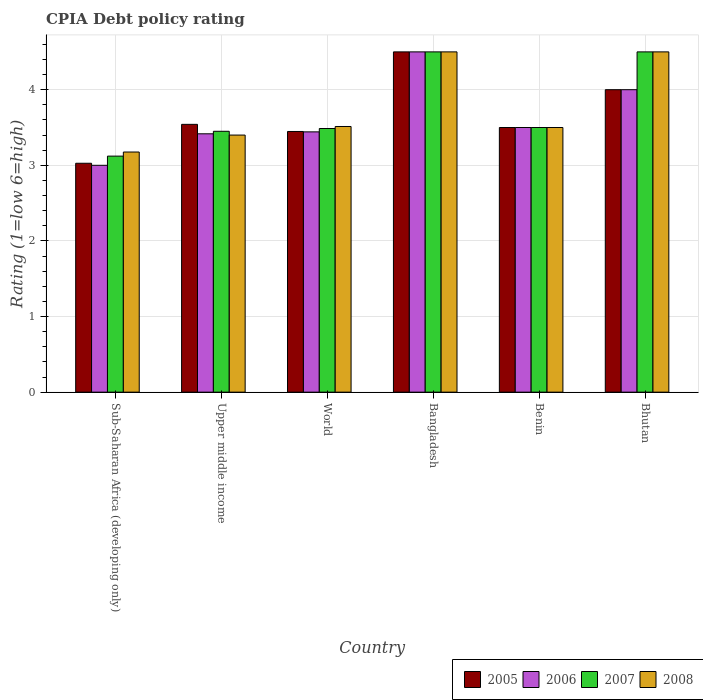How many different coloured bars are there?
Your response must be concise. 4. How many groups of bars are there?
Your answer should be compact. 6. Are the number of bars per tick equal to the number of legend labels?
Your response must be concise. Yes. How many bars are there on the 4th tick from the left?
Provide a short and direct response. 4. How many bars are there on the 5th tick from the right?
Give a very brief answer. 4. What is the label of the 5th group of bars from the left?
Make the answer very short. Benin. In how many cases, is the number of bars for a given country not equal to the number of legend labels?
Keep it short and to the point. 0. Across all countries, what is the maximum CPIA rating in 2005?
Provide a succinct answer. 4.5. Across all countries, what is the minimum CPIA rating in 2006?
Offer a terse response. 3. In which country was the CPIA rating in 2006 maximum?
Provide a short and direct response. Bangladesh. In which country was the CPIA rating in 2008 minimum?
Keep it short and to the point. Sub-Saharan Africa (developing only). What is the total CPIA rating in 2008 in the graph?
Provide a short and direct response. 22.59. What is the difference between the CPIA rating in 2007 in Bhutan and that in Sub-Saharan Africa (developing only)?
Make the answer very short. 1.38. What is the difference between the CPIA rating in 2005 in Sub-Saharan Africa (developing only) and the CPIA rating in 2007 in World?
Your answer should be very brief. -0.46. What is the average CPIA rating in 2006 per country?
Your answer should be compact. 3.64. What is the ratio of the CPIA rating in 2007 in Benin to that in Upper middle income?
Your answer should be compact. 1.01. What is the difference between the highest and the lowest CPIA rating in 2005?
Give a very brief answer. 1.47. What does the 3rd bar from the left in World represents?
Ensure brevity in your answer.  2007. How many bars are there?
Give a very brief answer. 24. Are all the bars in the graph horizontal?
Give a very brief answer. No. How many countries are there in the graph?
Make the answer very short. 6. What is the difference between two consecutive major ticks on the Y-axis?
Provide a short and direct response. 1. Does the graph contain any zero values?
Ensure brevity in your answer.  No. Does the graph contain grids?
Your response must be concise. Yes. How many legend labels are there?
Your response must be concise. 4. What is the title of the graph?
Offer a very short reply. CPIA Debt policy rating. What is the label or title of the X-axis?
Offer a terse response. Country. What is the Rating (1=low 6=high) of 2005 in Sub-Saharan Africa (developing only)?
Your answer should be very brief. 3.03. What is the Rating (1=low 6=high) in 2006 in Sub-Saharan Africa (developing only)?
Offer a terse response. 3. What is the Rating (1=low 6=high) in 2007 in Sub-Saharan Africa (developing only)?
Provide a short and direct response. 3.12. What is the Rating (1=low 6=high) in 2008 in Sub-Saharan Africa (developing only)?
Offer a very short reply. 3.18. What is the Rating (1=low 6=high) of 2005 in Upper middle income?
Provide a succinct answer. 3.54. What is the Rating (1=low 6=high) of 2006 in Upper middle income?
Your answer should be compact. 3.42. What is the Rating (1=low 6=high) of 2007 in Upper middle income?
Your answer should be very brief. 3.45. What is the Rating (1=low 6=high) of 2005 in World?
Offer a terse response. 3.45. What is the Rating (1=low 6=high) of 2006 in World?
Offer a very short reply. 3.44. What is the Rating (1=low 6=high) of 2007 in World?
Keep it short and to the point. 3.49. What is the Rating (1=low 6=high) in 2008 in World?
Offer a terse response. 3.51. What is the Rating (1=low 6=high) in 2005 in Bangladesh?
Provide a succinct answer. 4.5. What is the Rating (1=low 6=high) of 2006 in Bangladesh?
Provide a succinct answer. 4.5. What is the Rating (1=low 6=high) in 2007 in Bangladesh?
Offer a terse response. 4.5. What is the Rating (1=low 6=high) in 2006 in Benin?
Provide a succinct answer. 3.5. What is the Rating (1=low 6=high) in 2007 in Benin?
Offer a terse response. 3.5. What is the Rating (1=low 6=high) in 2008 in Benin?
Make the answer very short. 3.5. What is the Rating (1=low 6=high) of 2005 in Bhutan?
Your answer should be compact. 4. What is the Rating (1=low 6=high) in 2007 in Bhutan?
Offer a terse response. 4.5. What is the Rating (1=low 6=high) of 2008 in Bhutan?
Make the answer very short. 4.5. Across all countries, what is the maximum Rating (1=low 6=high) in 2005?
Offer a terse response. 4.5. Across all countries, what is the maximum Rating (1=low 6=high) of 2006?
Ensure brevity in your answer.  4.5. Across all countries, what is the maximum Rating (1=low 6=high) in 2007?
Give a very brief answer. 4.5. Across all countries, what is the maximum Rating (1=low 6=high) of 2008?
Offer a terse response. 4.5. Across all countries, what is the minimum Rating (1=low 6=high) in 2005?
Provide a succinct answer. 3.03. Across all countries, what is the minimum Rating (1=low 6=high) in 2007?
Ensure brevity in your answer.  3.12. Across all countries, what is the minimum Rating (1=low 6=high) of 2008?
Make the answer very short. 3.18. What is the total Rating (1=low 6=high) of 2005 in the graph?
Provide a succinct answer. 22.02. What is the total Rating (1=low 6=high) of 2006 in the graph?
Keep it short and to the point. 21.86. What is the total Rating (1=low 6=high) in 2007 in the graph?
Keep it short and to the point. 22.56. What is the total Rating (1=low 6=high) in 2008 in the graph?
Provide a short and direct response. 22.59. What is the difference between the Rating (1=low 6=high) in 2005 in Sub-Saharan Africa (developing only) and that in Upper middle income?
Provide a short and direct response. -0.51. What is the difference between the Rating (1=low 6=high) of 2006 in Sub-Saharan Africa (developing only) and that in Upper middle income?
Your response must be concise. -0.42. What is the difference between the Rating (1=low 6=high) in 2007 in Sub-Saharan Africa (developing only) and that in Upper middle income?
Your answer should be compact. -0.33. What is the difference between the Rating (1=low 6=high) in 2008 in Sub-Saharan Africa (developing only) and that in Upper middle income?
Give a very brief answer. -0.22. What is the difference between the Rating (1=low 6=high) in 2005 in Sub-Saharan Africa (developing only) and that in World?
Ensure brevity in your answer.  -0.42. What is the difference between the Rating (1=low 6=high) of 2006 in Sub-Saharan Africa (developing only) and that in World?
Your response must be concise. -0.44. What is the difference between the Rating (1=low 6=high) in 2007 in Sub-Saharan Africa (developing only) and that in World?
Your answer should be very brief. -0.36. What is the difference between the Rating (1=low 6=high) of 2008 in Sub-Saharan Africa (developing only) and that in World?
Your answer should be compact. -0.34. What is the difference between the Rating (1=low 6=high) of 2005 in Sub-Saharan Africa (developing only) and that in Bangladesh?
Provide a succinct answer. -1.47. What is the difference between the Rating (1=low 6=high) in 2007 in Sub-Saharan Africa (developing only) and that in Bangladesh?
Offer a terse response. -1.38. What is the difference between the Rating (1=low 6=high) in 2008 in Sub-Saharan Africa (developing only) and that in Bangladesh?
Keep it short and to the point. -1.32. What is the difference between the Rating (1=low 6=high) in 2005 in Sub-Saharan Africa (developing only) and that in Benin?
Your answer should be compact. -0.47. What is the difference between the Rating (1=low 6=high) of 2007 in Sub-Saharan Africa (developing only) and that in Benin?
Offer a terse response. -0.38. What is the difference between the Rating (1=low 6=high) of 2008 in Sub-Saharan Africa (developing only) and that in Benin?
Ensure brevity in your answer.  -0.32. What is the difference between the Rating (1=low 6=high) of 2005 in Sub-Saharan Africa (developing only) and that in Bhutan?
Keep it short and to the point. -0.97. What is the difference between the Rating (1=low 6=high) in 2007 in Sub-Saharan Africa (developing only) and that in Bhutan?
Make the answer very short. -1.38. What is the difference between the Rating (1=low 6=high) in 2008 in Sub-Saharan Africa (developing only) and that in Bhutan?
Offer a terse response. -1.32. What is the difference between the Rating (1=low 6=high) in 2005 in Upper middle income and that in World?
Offer a very short reply. 0.09. What is the difference between the Rating (1=low 6=high) of 2006 in Upper middle income and that in World?
Provide a short and direct response. -0.03. What is the difference between the Rating (1=low 6=high) in 2007 in Upper middle income and that in World?
Your answer should be compact. -0.04. What is the difference between the Rating (1=low 6=high) in 2008 in Upper middle income and that in World?
Offer a very short reply. -0.11. What is the difference between the Rating (1=low 6=high) of 2005 in Upper middle income and that in Bangladesh?
Provide a short and direct response. -0.96. What is the difference between the Rating (1=low 6=high) in 2006 in Upper middle income and that in Bangladesh?
Keep it short and to the point. -1.08. What is the difference between the Rating (1=low 6=high) in 2007 in Upper middle income and that in Bangladesh?
Give a very brief answer. -1.05. What is the difference between the Rating (1=low 6=high) in 2008 in Upper middle income and that in Bangladesh?
Keep it short and to the point. -1.1. What is the difference between the Rating (1=low 6=high) in 2005 in Upper middle income and that in Benin?
Your answer should be compact. 0.04. What is the difference between the Rating (1=low 6=high) in 2006 in Upper middle income and that in Benin?
Provide a short and direct response. -0.08. What is the difference between the Rating (1=low 6=high) in 2007 in Upper middle income and that in Benin?
Make the answer very short. -0.05. What is the difference between the Rating (1=low 6=high) of 2005 in Upper middle income and that in Bhutan?
Your answer should be compact. -0.46. What is the difference between the Rating (1=low 6=high) of 2006 in Upper middle income and that in Bhutan?
Make the answer very short. -0.58. What is the difference between the Rating (1=low 6=high) of 2007 in Upper middle income and that in Bhutan?
Keep it short and to the point. -1.05. What is the difference between the Rating (1=low 6=high) of 2005 in World and that in Bangladesh?
Provide a short and direct response. -1.05. What is the difference between the Rating (1=low 6=high) in 2006 in World and that in Bangladesh?
Provide a short and direct response. -1.06. What is the difference between the Rating (1=low 6=high) in 2007 in World and that in Bangladesh?
Offer a terse response. -1.01. What is the difference between the Rating (1=low 6=high) in 2008 in World and that in Bangladesh?
Offer a terse response. -0.99. What is the difference between the Rating (1=low 6=high) in 2005 in World and that in Benin?
Ensure brevity in your answer.  -0.05. What is the difference between the Rating (1=low 6=high) of 2006 in World and that in Benin?
Your answer should be compact. -0.06. What is the difference between the Rating (1=low 6=high) in 2007 in World and that in Benin?
Offer a terse response. -0.01. What is the difference between the Rating (1=low 6=high) in 2008 in World and that in Benin?
Offer a terse response. 0.01. What is the difference between the Rating (1=low 6=high) of 2005 in World and that in Bhutan?
Keep it short and to the point. -0.55. What is the difference between the Rating (1=low 6=high) of 2006 in World and that in Bhutan?
Ensure brevity in your answer.  -0.56. What is the difference between the Rating (1=low 6=high) in 2007 in World and that in Bhutan?
Your answer should be compact. -1.01. What is the difference between the Rating (1=low 6=high) of 2008 in World and that in Bhutan?
Your response must be concise. -0.99. What is the difference between the Rating (1=low 6=high) of 2006 in Bangladesh and that in Benin?
Offer a very short reply. 1. What is the difference between the Rating (1=low 6=high) in 2008 in Bangladesh and that in Benin?
Make the answer very short. 1. What is the difference between the Rating (1=low 6=high) in 2005 in Bangladesh and that in Bhutan?
Keep it short and to the point. 0.5. What is the difference between the Rating (1=low 6=high) of 2007 in Bangladesh and that in Bhutan?
Ensure brevity in your answer.  0. What is the difference between the Rating (1=low 6=high) of 2008 in Bangladesh and that in Bhutan?
Provide a succinct answer. 0. What is the difference between the Rating (1=low 6=high) of 2006 in Benin and that in Bhutan?
Ensure brevity in your answer.  -0.5. What is the difference between the Rating (1=low 6=high) in 2007 in Benin and that in Bhutan?
Your answer should be compact. -1. What is the difference between the Rating (1=low 6=high) of 2008 in Benin and that in Bhutan?
Give a very brief answer. -1. What is the difference between the Rating (1=low 6=high) in 2005 in Sub-Saharan Africa (developing only) and the Rating (1=low 6=high) in 2006 in Upper middle income?
Ensure brevity in your answer.  -0.39. What is the difference between the Rating (1=low 6=high) in 2005 in Sub-Saharan Africa (developing only) and the Rating (1=low 6=high) in 2007 in Upper middle income?
Your answer should be very brief. -0.42. What is the difference between the Rating (1=low 6=high) in 2005 in Sub-Saharan Africa (developing only) and the Rating (1=low 6=high) in 2008 in Upper middle income?
Your response must be concise. -0.37. What is the difference between the Rating (1=low 6=high) of 2006 in Sub-Saharan Africa (developing only) and the Rating (1=low 6=high) of 2007 in Upper middle income?
Your answer should be compact. -0.45. What is the difference between the Rating (1=low 6=high) of 2006 in Sub-Saharan Africa (developing only) and the Rating (1=low 6=high) of 2008 in Upper middle income?
Provide a short and direct response. -0.4. What is the difference between the Rating (1=low 6=high) of 2007 in Sub-Saharan Africa (developing only) and the Rating (1=low 6=high) of 2008 in Upper middle income?
Ensure brevity in your answer.  -0.28. What is the difference between the Rating (1=low 6=high) of 2005 in Sub-Saharan Africa (developing only) and the Rating (1=low 6=high) of 2006 in World?
Give a very brief answer. -0.42. What is the difference between the Rating (1=low 6=high) in 2005 in Sub-Saharan Africa (developing only) and the Rating (1=low 6=high) in 2007 in World?
Ensure brevity in your answer.  -0.46. What is the difference between the Rating (1=low 6=high) in 2005 in Sub-Saharan Africa (developing only) and the Rating (1=low 6=high) in 2008 in World?
Provide a succinct answer. -0.49. What is the difference between the Rating (1=low 6=high) in 2006 in Sub-Saharan Africa (developing only) and the Rating (1=low 6=high) in 2007 in World?
Keep it short and to the point. -0.49. What is the difference between the Rating (1=low 6=high) in 2006 in Sub-Saharan Africa (developing only) and the Rating (1=low 6=high) in 2008 in World?
Your answer should be very brief. -0.51. What is the difference between the Rating (1=low 6=high) in 2007 in Sub-Saharan Africa (developing only) and the Rating (1=low 6=high) in 2008 in World?
Give a very brief answer. -0.39. What is the difference between the Rating (1=low 6=high) in 2005 in Sub-Saharan Africa (developing only) and the Rating (1=low 6=high) in 2006 in Bangladesh?
Provide a succinct answer. -1.47. What is the difference between the Rating (1=low 6=high) of 2005 in Sub-Saharan Africa (developing only) and the Rating (1=low 6=high) of 2007 in Bangladesh?
Offer a terse response. -1.47. What is the difference between the Rating (1=low 6=high) in 2005 in Sub-Saharan Africa (developing only) and the Rating (1=low 6=high) in 2008 in Bangladesh?
Your response must be concise. -1.47. What is the difference between the Rating (1=low 6=high) in 2006 in Sub-Saharan Africa (developing only) and the Rating (1=low 6=high) in 2008 in Bangladesh?
Your response must be concise. -1.5. What is the difference between the Rating (1=low 6=high) of 2007 in Sub-Saharan Africa (developing only) and the Rating (1=low 6=high) of 2008 in Bangladesh?
Keep it short and to the point. -1.38. What is the difference between the Rating (1=low 6=high) of 2005 in Sub-Saharan Africa (developing only) and the Rating (1=low 6=high) of 2006 in Benin?
Provide a succinct answer. -0.47. What is the difference between the Rating (1=low 6=high) of 2005 in Sub-Saharan Africa (developing only) and the Rating (1=low 6=high) of 2007 in Benin?
Your answer should be compact. -0.47. What is the difference between the Rating (1=low 6=high) of 2005 in Sub-Saharan Africa (developing only) and the Rating (1=low 6=high) of 2008 in Benin?
Provide a succinct answer. -0.47. What is the difference between the Rating (1=low 6=high) of 2006 in Sub-Saharan Africa (developing only) and the Rating (1=low 6=high) of 2008 in Benin?
Keep it short and to the point. -0.5. What is the difference between the Rating (1=low 6=high) in 2007 in Sub-Saharan Africa (developing only) and the Rating (1=low 6=high) in 2008 in Benin?
Make the answer very short. -0.38. What is the difference between the Rating (1=low 6=high) in 2005 in Sub-Saharan Africa (developing only) and the Rating (1=low 6=high) in 2006 in Bhutan?
Your answer should be compact. -0.97. What is the difference between the Rating (1=low 6=high) in 2005 in Sub-Saharan Africa (developing only) and the Rating (1=low 6=high) in 2007 in Bhutan?
Provide a short and direct response. -1.47. What is the difference between the Rating (1=low 6=high) in 2005 in Sub-Saharan Africa (developing only) and the Rating (1=low 6=high) in 2008 in Bhutan?
Offer a terse response. -1.47. What is the difference between the Rating (1=low 6=high) of 2006 in Sub-Saharan Africa (developing only) and the Rating (1=low 6=high) of 2007 in Bhutan?
Offer a terse response. -1.5. What is the difference between the Rating (1=low 6=high) in 2006 in Sub-Saharan Africa (developing only) and the Rating (1=low 6=high) in 2008 in Bhutan?
Provide a short and direct response. -1.5. What is the difference between the Rating (1=low 6=high) of 2007 in Sub-Saharan Africa (developing only) and the Rating (1=low 6=high) of 2008 in Bhutan?
Make the answer very short. -1.38. What is the difference between the Rating (1=low 6=high) in 2005 in Upper middle income and the Rating (1=low 6=high) in 2006 in World?
Give a very brief answer. 0.1. What is the difference between the Rating (1=low 6=high) in 2005 in Upper middle income and the Rating (1=low 6=high) in 2007 in World?
Provide a short and direct response. 0.06. What is the difference between the Rating (1=low 6=high) of 2005 in Upper middle income and the Rating (1=low 6=high) of 2008 in World?
Ensure brevity in your answer.  0.03. What is the difference between the Rating (1=low 6=high) of 2006 in Upper middle income and the Rating (1=low 6=high) of 2007 in World?
Provide a succinct answer. -0.07. What is the difference between the Rating (1=low 6=high) of 2006 in Upper middle income and the Rating (1=low 6=high) of 2008 in World?
Ensure brevity in your answer.  -0.1. What is the difference between the Rating (1=low 6=high) of 2007 in Upper middle income and the Rating (1=low 6=high) of 2008 in World?
Provide a succinct answer. -0.06. What is the difference between the Rating (1=low 6=high) of 2005 in Upper middle income and the Rating (1=low 6=high) of 2006 in Bangladesh?
Your answer should be very brief. -0.96. What is the difference between the Rating (1=low 6=high) in 2005 in Upper middle income and the Rating (1=low 6=high) in 2007 in Bangladesh?
Offer a terse response. -0.96. What is the difference between the Rating (1=low 6=high) of 2005 in Upper middle income and the Rating (1=low 6=high) of 2008 in Bangladesh?
Offer a terse response. -0.96. What is the difference between the Rating (1=low 6=high) of 2006 in Upper middle income and the Rating (1=low 6=high) of 2007 in Bangladesh?
Offer a terse response. -1.08. What is the difference between the Rating (1=low 6=high) in 2006 in Upper middle income and the Rating (1=low 6=high) in 2008 in Bangladesh?
Provide a succinct answer. -1.08. What is the difference between the Rating (1=low 6=high) in 2007 in Upper middle income and the Rating (1=low 6=high) in 2008 in Bangladesh?
Offer a terse response. -1.05. What is the difference between the Rating (1=low 6=high) of 2005 in Upper middle income and the Rating (1=low 6=high) of 2006 in Benin?
Your response must be concise. 0.04. What is the difference between the Rating (1=low 6=high) of 2005 in Upper middle income and the Rating (1=low 6=high) of 2007 in Benin?
Offer a terse response. 0.04. What is the difference between the Rating (1=low 6=high) in 2005 in Upper middle income and the Rating (1=low 6=high) in 2008 in Benin?
Your answer should be very brief. 0.04. What is the difference between the Rating (1=low 6=high) in 2006 in Upper middle income and the Rating (1=low 6=high) in 2007 in Benin?
Your response must be concise. -0.08. What is the difference between the Rating (1=low 6=high) in 2006 in Upper middle income and the Rating (1=low 6=high) in 2008 in Benin?
Keep it short and to the point. -0.08. What is the difference between the Rating (1=low 6=high) in 2005 in Upper middle income and the Rating (1=low 6=high) in 2006 in Bhutan?
Make the answer very short. -0.46. What is the difference between the Rating (1=low 6=high) in 2005 in Upper middle income and the Rating (1=low 6=high) in 2007 in Bhutan?
Your answer should be very brief. -0.96. What is the difference between the Rating (1=low 6=high) in 2005 in Upper middle income and the Rating (1=low 6=high) in 2008 in Bhutan?
Offer a very short reply. -0.96. What is the difference between the Rating (1=low 6=high) of 2006 in Upper middle income and the Rating (1=low 6=high) of 2007 in Bhutan?
Your answer should be very brief. -1.08. What is the difference between the Rating (1=low 6=high) in 2006 in Upper middle income and the Rating (1=low 6=high) in 2008 in Bhutan?
Your response must be concise. -1.08. What is the difference between the Rating (1=low 6=high) of 2007 in Upper middle income and the Rating (1=low 6=high) of 2008 in Bhutan?
Your answer should be compact. -1.05. What is the difference between the Rating (1=low 6=high) of 2005 in World and the Rating (1=low 6=high) of 2006 in Bangladesh?
Provide a succinct answer. -1.05. What is the difference between the Rating (1=low 6=high) of 2005 in World and the Rating (1=low 6=high) of 2007 in Bangladesh?
Offer a very short reply. -1.05. What is the difference between the Rating (1=low 6=high) in 2005 in World and the Rating (1=low 6=high) in 2008 in Bangladesh?
Your answer should be very brief. -1.05. What is the difference between the Rating (1=low 6=high) of 2006 in World and the Rating (1=low 6=high) of 2007 in Bangladesh?
Keep it short and to the point. -1.06. What is the difference between the Rating (1=low 6=high) in 2006 in World and the Rating (1=low 6=high) in 2008 in Bangladesh?
Offer a very short reply. -1.06. What is the difference between the Rating (1=low 6=high) in 2007 in World and the Rating (1=low 6=high) in 2008 in Bangladesh?
Provide a succinct answer. -1.01. What is the difference between the Rating (1=low 6=high) in 2005 in World and the Rating (1=low 6=high) in 2006 in Benin?
Ensure brevity in your answer.  -0.05. What is the difference between the Rating (1=low 6=high) in 2005 in World and the Rating (1=low 6=high) in 2007 in Benin?
Your answer should be compact. -0.05. What is the difference between the Rating (1=low 6=high) of 2005 in World and the Rating (1=low 6=high) of 2008 in Benin?
Ensure brevity in your answer.  -0.05. What is the difference between the Rating (1=low 6=high) in 2006 in World and the Rating (1=low 6=high) in 2007 in Benin?
Ensure brevity in your answer.  -0.06. What is the difference between the Rating (1=low 6=high) in 2006 in World and the Rating (1=low 6=high) in 2008 in Benin?
Your answer should be compact. -0.06. What is the difference between the Rating (1=low 6=high) in 2007 in World and the Rating (1=low 6=high) in 2008 in Benin?
Your response must be concise. -0.01. What is the difference between the Rating (1=low 6=high) of 2005 in World and the Rating (1=low 6=high) of 2006 in Bhutan?
Your response must be concise. -0.55. What is the difference between the Rating (1=low 6=high) of 2005 in World and the Rating (1=low 6=high) of 2007 in Bhutan?
Keep it short and to the point. -1.05. What is the difference between the Rating (1=low 6=high) of 2005 in World and the Rating (1=low 6=high) of 2008 in Bhutan?
Your answer should be very brief. -1.05. What is the difference between the Rating (1=low 6=high) of 2006 in World and the Rating (1=low 6=high) of 2007 in Bhutan?
Your answer should be compact. -1.06. What is the difference between the Rating (1=low 6=high) in 2006 in World and the Rating (1=low 6=high) in 2008 in Bhutan?
Ensure brevity in your answer.  -1.06. What is the difference between the Rating (1=low 6=high) of 2007 in World and the Rating (1=low 6=high) of 2008 in Bhutan?
Provide a succinct answer. -1.01. What is the difference between the Rating (1=low 6=high) in 2005 in Bangladesh and the Rating (1=low 6=high) in 2006 in Benin?
Offer a terse response. 1. What is the difference between the Rating (1=low 6=high) of 2005 in Bangladesh and the Rating (1=low 6=high) of 2007 in Benin?
Give a very brief answer. 1. What is the difference between the Rating (1=low 6=high) in 2006 in Bangladesh and the Rating (1=low 6=high) in 2008 in Benin?
Ensure brevity in your answer.  1. What is the difference between the Rating (1=low 6=high) in 2005 in Bangladesh and the Rating (1=low 6=high) in 2008 in Bhutan?
Ensure brevity in your answer.  0. What is the difference between the Rating (1=low 6=high) of 2007 in Bangladesh and the Rating (1=low 6=high) of 2008 in Bhutan?
Ensure brevity in your answer.  0. What is the difference between the Rating (1=low 6=high) of 2005 in Benin and the Rating (1=low 6=high) of 2008 in Bhutan?
Offer a very short reply. -1. What is the difference between the Rating (1=low 6=high) of 2006 in Benin and the Rating (1=low 6=high) of 2008 in Bhutan?
Make the answer very short. -1. What is the average Rating (1=low 6=high) in 2005 per country?
Provide a succinct answer. 3.67. What is the average Rating (1=low 6=high) in 2006 per country?
Your answer should be very brief. 3.64. What is the average Rating (1=low 6=high) in 2007 per country?
Ensure brevity in your answer.  3.76. What is the average Rating (1=low 6=high) in 2008 per country?
Offer a very short reply. 3.76. What is the difference between the Rating (1=low 6=high) in 2005 and Rating (1=low 6=high) in 2006 in Sub-Saharan Africa (developing only)?
Ensure brevity in your answer.  0.03. What is the difference between the Rating (1=low 6=high) of 2005 and Rating (1=low 6=high) of 2007 in Sub-Saharan Africa (developing only)?
Make the answer very short. -0.09. What is the difference between the Rating (1=low 6=high) of 2005 and Rating (1=low 6=high) of 2008 in Sub-Saharan Africa (developing only)?
Make the answer very short. -0.15. What is the difference between the Rating (1=low 6=high) in 2006 and Rating (1=low 6=high) in 2007 in Sub-Saharan Africa (developing only)?
Your answer should be compact. -0.12. What is the difference between the Rating (1=low 6=high) in 2006 and Rating (1=low 6=high) in 2008 in Sub-Saharan Africa (developing only)?
Make the answer very short. -0.18. What is the difference between the Rating (1=low 6=high) of 2007 and Rating (1=low 6=high) of 2008 in Sub-Saharan Africa (developing only)?
Provide a succinct answer. -0.05. What is the difference between the Rating (1=low 6=high) of 2005 and Rating (1=low 6=high) of 2007 in Upper middle income?
Your response must be concise. 0.09. What is the difference between the Rating (1=low 6=high) in 2005 and Rating (1=low 6=high) in 2008 in Upper middle income?
Provide a short and direct response. 0.14. What is the difference between the Rating (1=low 6=high) in 2006 and Rating (1=low 6=high) in 2007 in Upper middle income?
Your answer should be compact. -0.03. What is the difference between the Rating (1=low 6=high) in 2006 and Rating (1=low 6=high) in 2008 in Upper middle income?
Provide a succinct answer. 0.02. What is the difference between the Rating (1=low 6=high) in 2005 and Rating (1=low 6=high) in 2006 in World?
Provide a succinct answer. 0.01. What is the difference between the Rating (1=low 6=high) of 2005 and Rating (1=low 6=high) of 2007 in World?
Ensure brevity in your answer.  -0.04. What is the difference between the Rating (1=low 6=high) in 2005 and Rating (1=low 6=high) in 2008 in World?
Provide a succinct answer. -0.07. What is the difference between the Rating (1=low 6=high) in 2006 and Rating (1=low 6=high) in 2007 in World?
Your response must be concise. -0.04. What is the difference between the Rating (1=low 6=high) of 2006 and Rating (1=low 6=high) of 2008 in World?
Your answer should be very brief. -0.07. What is the difference between the Rating (1=low 6=high) in 2007 and Rating (1=low 6=high) in 2008 in World?
Ensure brevity in your answer.  -0.03. What is the difference between the Rating (1=low 6=high) in 2005 and Rating (1=low 6=high) in 2006 in Bangladesh?
Your answer should be very brief. 0. What is the difference between the Rating (1=low 6=high) of 2005 and Rating (1=low 6=high) of 2007 in Bangladesh?
Ensure brevity in your answer.  0. What is the difference between the Rating (1=low 6=high) of 2006 and Rating (1=low 6=high) of 2008 in Bangladesh?
Make the answer very short. 0. What is the difference between the Rating (1=low 6=high) in 2007 and Rating (1=low 6=high) in 2008 in Bangladesh?
Give a very brief answer. 0. What is the difference between the Rating (1=low 6=high) of 2005 and Rating (1=low 6=high) of 2007 in Benin?
Your answer should be very brief. 0. What is the difference between the Rating (1=low 6=high) of 2005 and Rating (1=low 6=high) of 2008 in Benin?
Your answer should be compact. 0. What is the difference between the Rating (1=low 6=high) in 2006 and Rating (1=low 6=high) in 2007 in Benin?
Your response must be concise. 0. What is the difference between the Rating (1=low 6=high) in 2007 and Rating (1=low 6=high) in 2008 in Benin?
Provide a succinct answer. 0. What is the difference between the Rating (1=low 6=high) of 2005 and Rating (1=low 6=high) of 2007 in Bhutan?
Your response must be concise. -0.5. What is the difference between the Rating (1=low 6=high) of 2005 and Rating (1=low 6=high) of 2008 in Bhutan?
Your answer should be compact. -0.5. What is the difference between the Rating (1=low 6=high) of 2006 and Rating (1=low 6=high) of 2007 in Bhutan?
Your answer should be compact. -0.5. What is the difference between the Rating (1=low 6=high) in 2007 and Rating (1=low 6=high) in 2008 in Bhutan?
Offer a very short reply. 0. What is the ratio of the Rating (1=low 6=high) in 2005 in Sub-Saharan Africa (developing only) to that in Upper middle income?
Provide a succinct answer. 0.85. What is the ratio of the Rating (1=low 6=high) in 2006 in Sub-Saharan Africa (developing only) to that in Upper middle income?
Your answer should be compact. 0.88. What is the ratio of the Rating (1=low 6=high) of 2007 in Sub-Saharan Africa (developing only) to that in Upper middle income?
Provide a short and direct response. 0.9. What is the ratio of the Rating (1=low 6=high) of 2008 in Sub-Saharan Africa (developing only) to that in Upper middle income?
Give a very brief answer. 0.93. What is the ratio of the Rating (1=low 6=high) of 2005 in Sub-Saharan Africa (developing only) to that in World?
Give a very brief answer. 0.88. What is the ratio of the Rating (1=low 6=high) of 2006 in Sub-Saharan Africa (developing only) to that in World?
Your answer should be compact. 0.87. What is the ratio of the Rating (1=low 6=high) in 2007 in Sub-Saharan Africa (developing only) to that in World?
Keep it short and to the point. 0.9. What is the ratio of the Rating (1=low 6=high) in 2008 in Sub-Saharan Africa (developing only) to that in World?
Offer a very short reply. 0.9. What is the ratio of the Rating (1=low 6=high) of 2005 in Sub-Saharan Africa (developing only) to that in Bangladesh?
Your answer should be compact. 0.67. What is the ratio of the Rating (1=low 6=high) in 2006 in Sub-Saharan Africa (developing only) to that in Bangladesh?
Offer a very short reply. 0.67. What is the ratio of the Rating (1=low 6=high) of 2007 in Sub-Saharan Africa (developing only) to that in Bangladesh?
Offer a very short reply. 0.69. What is the ratio of the Rating (1=low 6=high) in 2008 in Sub-Saharan Africa (developing only) to that in Bangladesh?
Your answer should be very brief. 0.71. What is the ratio of the Rating (1=low 6=high) of 2005 in Sub-Saharan Africa (developing only) to that in Benin?
Your answer should be very brief. 0.86. What is the ratio of the Rating (1=low 6=high) of 2007 in Sub-Saharan Africa (developing only) to that in Benin?
Provide a succinct answer. 0.89. What is the ratio of the Rating (1=low 6=high) of 2008 in Sub-Saharan Africa (developing only) to that in Benin?
Keep it short and to the point. 0.91. What is the ratio of the Rating (1=low 6=high) of 2005 in Sub-Saharan Africa (developing only) to that in Bhutan?
Ensure brevity in your answer.  0.76. What is the ratio of the Rating (1=low 6=high) in 2007 in Sub-Saharan Africa (developing only) to that in Bhutan?
Your response must be concise. 0.69. What is the ratio of the Rating (1=low 6=high) of 2008 in Sub-Saharan Africa (developing only) to that in Bhutan?
Give a very brief answer. 0.71. What is the ratio of the Rating (1=low 6=high) of 2005 in Upper middle income to that in World?
Your response must be concise. 1.03. What is the ratio of the Rating (1=low 6=high) of 2006 in Upper middle income to that in World?
Provide a short and direct response. 0.99. What is the ratio of the Rating (1=low 6=high) of 2007 in Upper middle income to that in World?
Your answer should be compact. 0.99. What is the ratio of the Rating (1=low 6=high) of 2008 in Upper middle income to that in World?
Your answer should be very brief. 0.97. What is the ratio of the Rating (1=low 6=high) in 2005 in Upper middle income to that in Bangladesh?
Keep it short and to the point. 0.79. What is the ratio of the Rating (1=low 6=high) in 2006 in Upper middle income to that in Bangladesh?
Keep it short and to the point. 0.76. What is the ratio of the Rating (1=low 6=high) in 2007 in Upper middle income to that in Bangladesh?
Offer a terse response. 0.77. What is the ratio of the Rating (1=low 6=high) in 2008 in Upper middle income to that in Bangladesh?
Provide a short and direct response. 0.76. What is the ratio of the Rating (1=low 6=high) of 2005 in Upper middle income to that in Benin?
Ensure brevity in your answer.  1.01. What is the ratio of the Rating (1=low 6=high) of 2006 in Upper middle income to that in Benin?
Your answer should be compact. 0.98. What is the ratio of the Rating (1=low 6=high) in 2007 in Upper middle income to that in Benin?
Offer a very short reply. 0.99. What is the ratio of the Rating (1=low 6=high) in 2008 in Upper middle income to that in Benin?
Offer a terse response. 0.97. What is the ratio of the Rating (1=low 6=high) in 2005 in Upper middle income to that in Bhutan?
Your answer should be very brief. 0.89. What is the ratio of the Rating (1=low 6=high) of 2006 in Upper middle income to that in Bhutan?
Provide a succinct answer. 0.85. What is the ratio of the Rating (1=low 6=high) of 2007 in Upper middle income to that in Bhutan?
Make the answer very short. 0.77. What is the ratio of the Rating (1=low 6=high) in 2008 in Upper middle income to that in Bhutan?
Offer a very short reply. 0.76. What is the ratio of the Rating (1=low 6=high) of 2005 in World to that in Bangladesh?
Offer a terse response. 0.77. What is the ratio of the Rating (1=low 6=high) in 2006 in World to that in Bangladesh?
Provide a short and direct response. 0.77. What is the ratio of the Rating (1=low 6=high) of 2007 in World to that in Bangladesh?
Your answer should be very brief. 0.77. What is the ratio of the Rating (1=low 6=high) of 2008 in World to that in Bangladesh?
Your answer should be compact. 0.78. What is the ratio of the Rating (1=low 6=high) of 2005 in World to that in Benin?
Provide a succinct answer. 0.98. What is the ratio of the Rating (1=low 6=high) of 2006 in World to that in Benin?
Give a very brief answer. 0.98. What is the ratio of the Rating (1=low 6=high) in 2005 in World to that in Bhutan?
Make the answer very short. 0.86. What is the ratio of the Rating (1=low 6=high) of 2006 in World to that in Bhutan?
Offer a very short reply. 0.86. What is the ratio of the Rating (1=low 6=high) in 2007 in World to that in Bhutan?
Offer a terse response. 0.77. What is the ratio of the Rating (1=low 6=high) of 2008 in World to that in Bhutan?
Provide a succinct answer. 0.78. What is the ratio of the Rating (1=low 6=high) in 2005 in Bangladesh to that in Benin?
Offer a terse response. 1.29. What is the ratio of the Rating (1=low 6=high) in 2007 in Bangladesh to that in Benin?
Make the answer very short. 1.29. What is the ratio of the Rating (1=low 6=high) in 2008 in Bangladesh to that in Benin?
Offer a terse response. 1.29. What is the ratio of the Rating (1=low 6=high) in 2005 in Bangladesh to that in Bhutan?
Keep it short and to the point. 1.12. What is the ratio of the Rating (1=low 6=high) in 2006 in Bangladesh to that in Bhutan?
Ensure brevity in your answer.  1.12. What is the ratio of the Rating (1=low 6=high) in 2008 in Bangladesh to that in Bhutan?
Ensure brevity in your answer.  1. What is the ratio of the Rating (1=low 6=high) in 2005 in Benin to that in Bhutan?
Your response must be concise. 0.88. What is the difference between the highest and the second highest Rating (1=low 6=high) of 2005?
Your response must be concise. 0.5. What is the difference between the highest and the lowest Rating (1=low 6=high) of 2005?
Offer a terse response. 1.47. What is the difference between the highest and the lowest Rating (1=low 6=high) in 2006?
Offer a very short reply. 1.5. What is the difference between the highest and the lowest Rating (1=low 6=high) in 2007?
Your answer should be compact. 1.38. What is the difference between the highest and the lowest Rating (1=low 6=high) of 2008?
Provide a short and direct response. 1.32. 